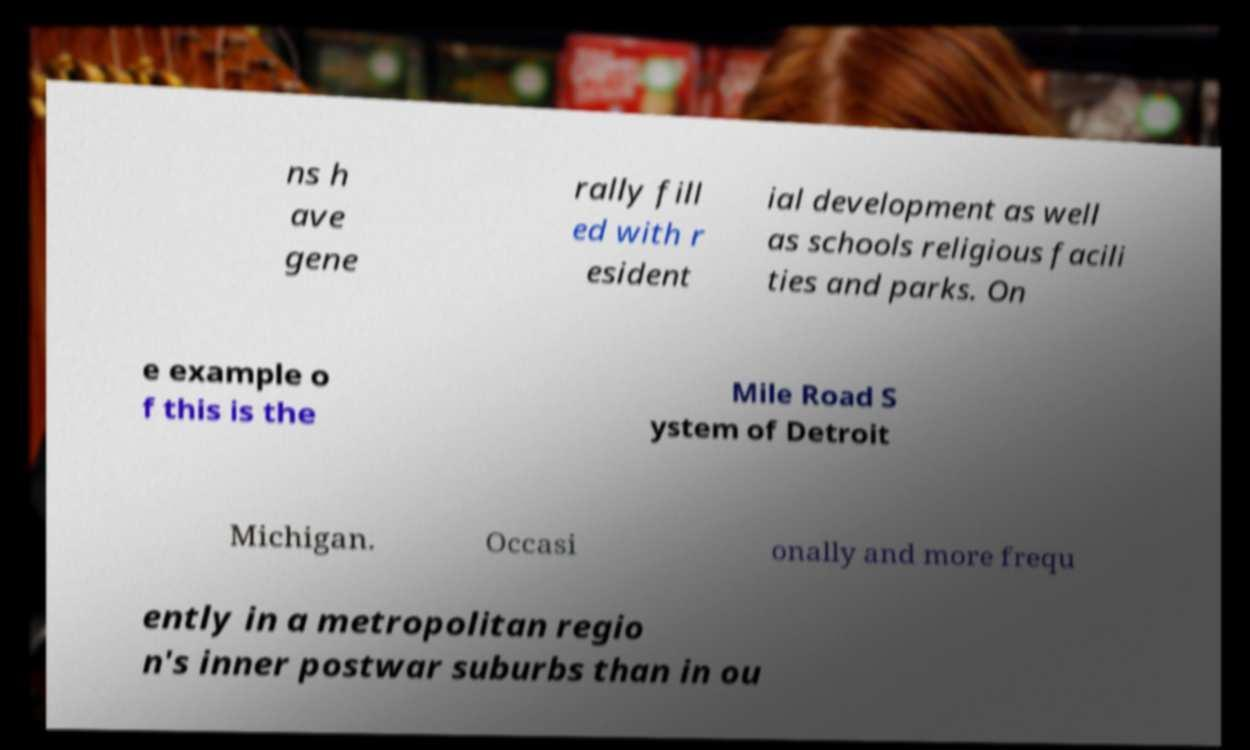Could you assist in decoding the text presented in this image and type it out clearly? ns h ave gene rally fill ed with r esident ial development as well as schools religious facili ties and parks. On e example o f this is the Mile Road S ystem of Detroit Michigan. Occasi onally and more frequ ently in a metropolitan regio n's inner postwar suburbs than in ou 